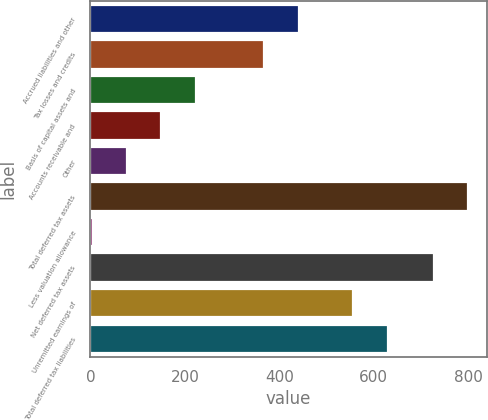Convert chart. <chart><loc_0><loc_0><loc_500><loc_500><bar_chart><fcel>Accrued liabilities and other<fcel>Tax losses and credits<fcel>Basis of capital assets and<fcel>Accounts receivable and<fcel>Other<fcel>Total deferred tax assets<fcel>Less valuation allowance<fcel>Net deferred tax assets<fcel>Unremitted earnings of<fcel>Total deferred tax liabilities<nl><fcel>441.2<fcel>368.5<fcel>223.1<fcel>150.4<fcel>77.7<fcel>799.7<fcel>5<fcel>727<fcel>557<fcel>629.7<nl></chart> 